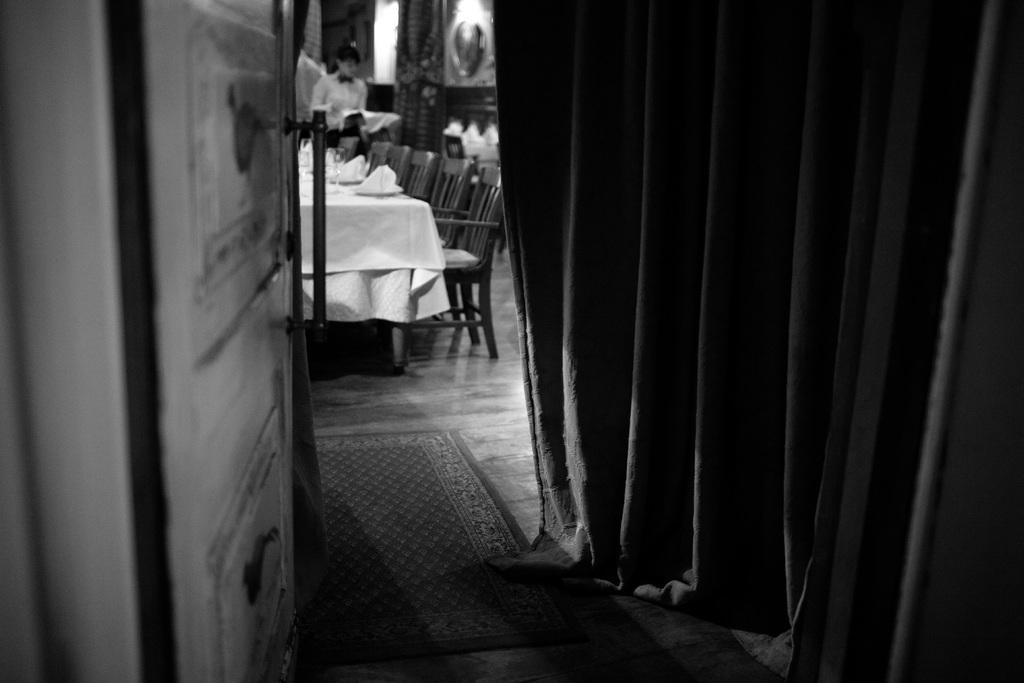What type of furniture is present in the image? There is a chair and a table in the image. What architectural feature can be seen in the image? There is a door in the image. What is the color scheme of the image? The image is in black and white color. Can you see any flesh in the image? There is no flesh visible in the image, as it is in black and white color and does not depict any living beings. Is there a boat in the image? There is no boat present in the image; it only features a chair, table, and door. 